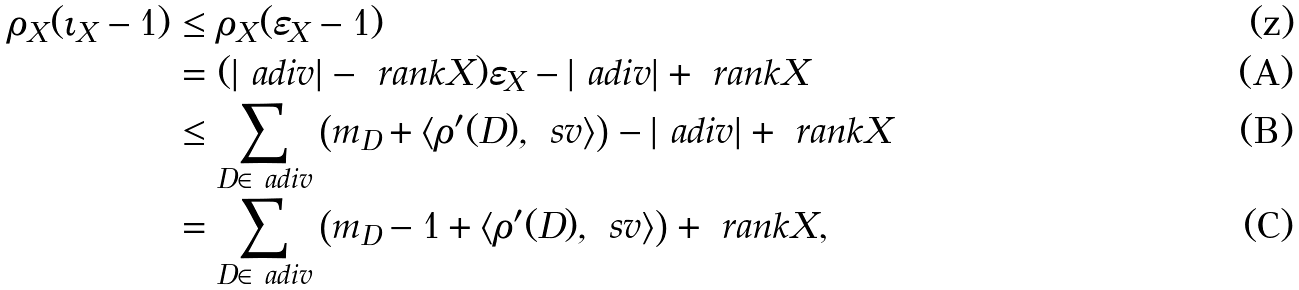<formula> <loc_0><loc_0><loc_500><loc_500>\rho _ { X } ( \iota _ { X } - 1 ) & \leq \rho _ { X } ( \varepsilon _ { X } - 1 ) \\ & = ( | \ a d i v | - \ r a n k X ) \varepsilon _ { X } - | \ a d i v | + \ r a n k X \\ & \leq \sum _ { D \in \ a d i v } \left ( m _ { D } + \langle \rho ^ { \prime } ( D ) , \ s v \rangle \right ) - | \ a d i v | + \ r a n k X \\ & = \sum _ { D \in \ a d i v } \left ( m _ { D } - 1 + \langle \rho ^ { \prime } ( D ) , \ s v \rangle \right ) + \ r a n k X \text {,}</formula> 